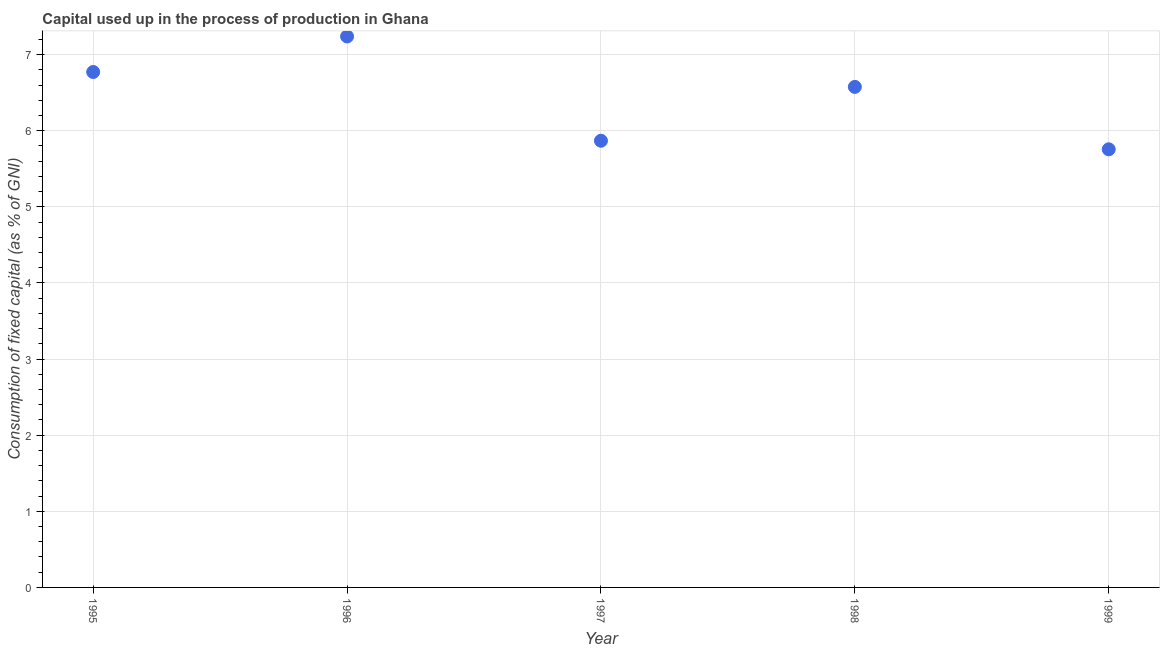What is the consumption of fixed capital in 1998?
Offer a very short reply. 6.58. Across all years, what is the maximum consumption of fixed capital?
Ensure brevity in your answer.  7.24. Across all years, what is the minimum consumption of fixed capital?
Provide a succinct answer. 5.76. In which year was the consumption of fixed capital minimum?
Provide a succinct answer. 1999. What is the sum of the consumption of fixed capital?
Give a very brief answer. 32.21. What is the difference between the consumption of fixed capital in 1995 and 1998?
Your response must be concise. 0.2. What is the average consumption of fixed capital per year?
Make the answer very short. 6.44. What is the median consumption of fixed capital?
Provide a succinct answer. 6.58. What is the ratio of the consumption of fixed capital in 1995 to that in 1996?
Provide a short and direct response. 0.94. Is the consumption of fixed capital in 1995 less than that in 1999?
Offer a very short reply. No. Is the difference between the consumption of fixed capital in 1995 and 1996 greater than the difference between any two years?
Provide a short and direct response. No. What is the difference between the highest and the second highest consumption of fixed capital?
Keep it short and to the point. 0.47. What is the difference between the highest and the lowest consumption of fixed capital?
Provide a short and direct response. 1.48. Does the consumption of fixed capital monotonically increase over the years?
Provide a short and direct response. No. How many dotlines are there?
Your answer should be very brief. 1. How many years are there in the graph?
Ensure brevity in your answer.  5. What is the title of the graph?
Ensure brevity in your answer.  Capital used up in the process of production in Ghana. What is the label or title of the X-axis?
Your answer should be very brief. Year. What is the label or title of the Y-axis?
Your answer should be compact. Consumption of fixed capital (as % of GNI). What is the Consumption of fixed capital (as % of GNI) in 1995?
Provide a short and direct response. 6.77. What is the Consumption of fixed capital (as % of GNI) in 1996?
Your answer should be very brief. 7.24. What is the Consumption of fixed capital (as % of GNI) in 1997?
Ensure brevity in your answer.  5.87. What is the Consumption of fixed capital (as % of GNI) in 1998?
Your answer should be compact. 6.58. What is the Consumption of fixed capital (as % of GNI) in 1999?
Give a very brief answer. 5.76. What is the difference between the Consumption of fixed capital (as % of GNI) in 1995 and 1996?
Provide a succinct answer. -0.47. What is the difference between the Consumption of fixed capital (as % of GNI) in 1995 and 1997?
Offer a very short reply. 0.9. What is the difference between the Consumption of fixed capital (as % of GNI) in 1995 and 1998?
Your response must be concise. 0.2. What is the difference between the Consumption of fixed capital (as % of GNI) in 1995 and 1999?
Your response must be concise. 1.02. What is the difference between the Consumption of fixed capital (as % of GNI) in 1996 and 1997?
Provide a succinct answer. 1.37. What is the difference between the Consumption of fixed capital (as % of GNI) in 1996 and 1998?
Your response must be concise. 0.66. What is the difference between the Consumption of fixed capital (as % of GNI) in 1996 and 1999?
Keep it short and to the point. 1.48. What is the difference between the Consumption of fixed capital (as % of GNI) in 1997 and 1998?
Provide a short and direct response. -0.71. What is the difference between the Consumption of fixed capital (as % of GNI) in 1997 and 1999?
Your response must be concise. 0.11. What is the difference between the Consumption of fixed capital (as % of GNI) in 1998 and 1999?
Your answer should be very brief. 0.82. What is the ratio of the Consumption of fixed capital (as % of GNI) in 1995 to that in 1996?
Your response must be concise. 0.94. What is the ratio of the Consumption of fixed capital (as % of GNI) in 1995 to that in 1997?
Give a very brief answer. 1.15. What is the ratio of the Consumption of fixed capital (as % of GNI) in 1995 to that in 1998?
Your response must be concise. 1.03. What is the ratio of the Consumption of fixed capital (as % of GNI) in 1995 to that in 1999?
Offer a terse response. 1.18. What is the ratio of the Consumption of fixed capital (as % of GNI) in 1996 to that in 1997?
Keep it short and to the point. 1.23. What is the ratio of the Consumption of fixed capital (as % of GNI) in 1996 to that in 1998?
Provide a short and direct response. 1.1. What is the ratio of the Consumption of fixed capital (as % of GNI) in 1996 to that in 1999?
Provide a succinct answer. 1.26. What is the ratio of the Consumption of fixed capital (as % of GNI) in 1997 to that in 1998?
Ensure brevity in your answer.  0.89. What is the ratio of the Consumption of fixed capital (as % of GNI) in 1997 to that in 1999?
Give a very brief answer. 1.02. What is the ratio of the Consumption of fixed capital (as % of GNI) in 1998 to that in 1999?
Offer a very short reply. 1.14. 